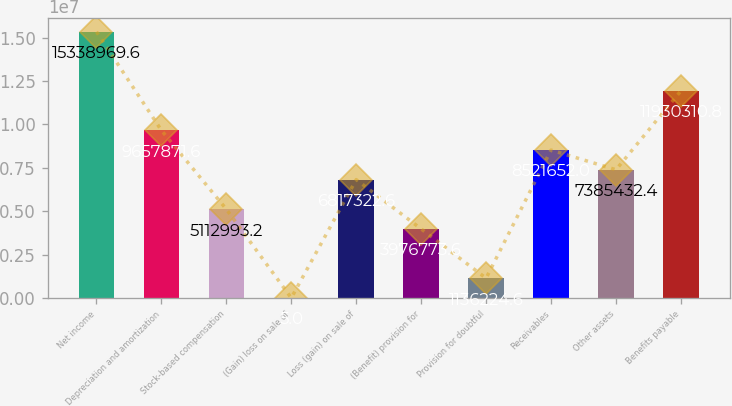<chart> <loc_0><loc_0><loc_500><loc_500><bar_chart><fcel>Net income<fcel>Depreciation and amortization<fcel>Stock-based compensation<fcel>(Gain) loss on sale of<fcel>Loss (gain) on sale of<fcel>(Benefit) provision for<fcel>Provision for doubtful<fcel>Receivables<fcel>Other assets<fcel>Benefits payable<nl><fcel>1.5339e+07<fcel>9.65787e+06<fcel>5.11299e+06<fcel>5<fcel>6.81732e+06<fcel>3.97677e+06<fcel>1.13622e+06<fcel>8.52165e+06<fcel>7.38543e+06<fcel>1.19303e+07<nl></chart> 